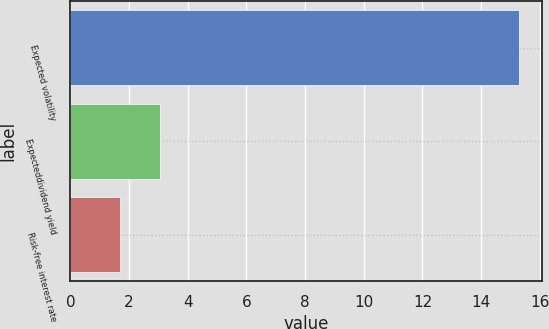Convert chart to OTSL. <chart><loc_0><loc_0><loc_500><loc_500><bar_chart><fcel>Expected volatility<fcel>Expecteddividend yield<fcel>Risk-free interest rate<nl><fcel>15.3<fcel>3.06<fcel>1.7<nl></chart> 